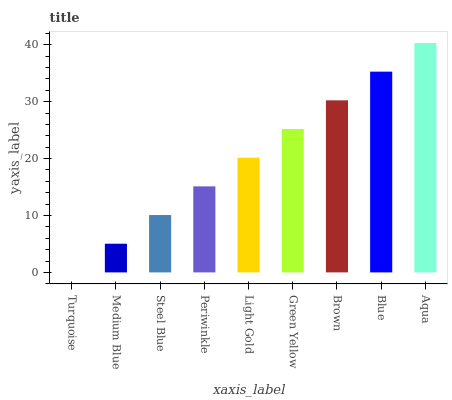Is Turquoise the minimum?
Answer yes or no. Yes. Is Aqua the maximum?
Answer yes or no. Yes. Is Medium Blue the minimum?
Answer yes or no. No. Is Medium Blue the maximum?
Answer yes or no. No. Is Medium Blue greater than Turquoise?
Answer yes or no. Yes. Is Turquoise less than Medium Blue?
Answer yes or no. Yes. Is Turquoise greater than Medium Blue?
Answer yes or no. No. Is Medium Blue less than Turquoise?
Answer yes or no. No. Is Light Gold the high median?
Answer yes or no. Yes. Is Light Gold the low median?
Answer yes or no. Yes. Is Periwinkle the high median?
Answer yes or no. No. Is Steel Blue the low median?
Answer yes or no. No. 